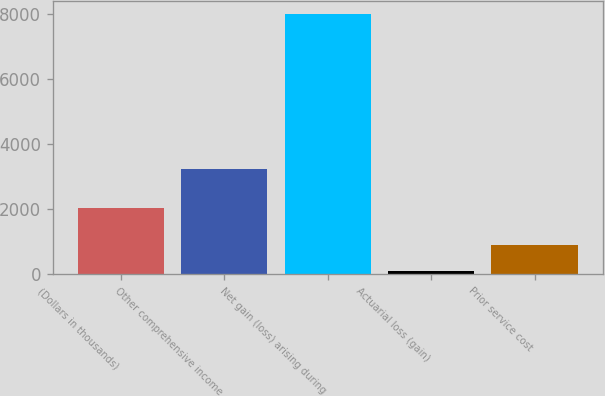Convert chart. <chart><loc_0><loc_0><loc_500><loc_500><bar_chart><fcel>(Dollars in thousands)<fcel>Other comprehensive income<fcel>Net gain (loss) arising during<fcel>Actuarial loss (gain)<fcel>Prior service cost<nl><fcel>2018<fcel>3242<fcel>7985<fcel>94<fcel>883.1<nl></chart> 